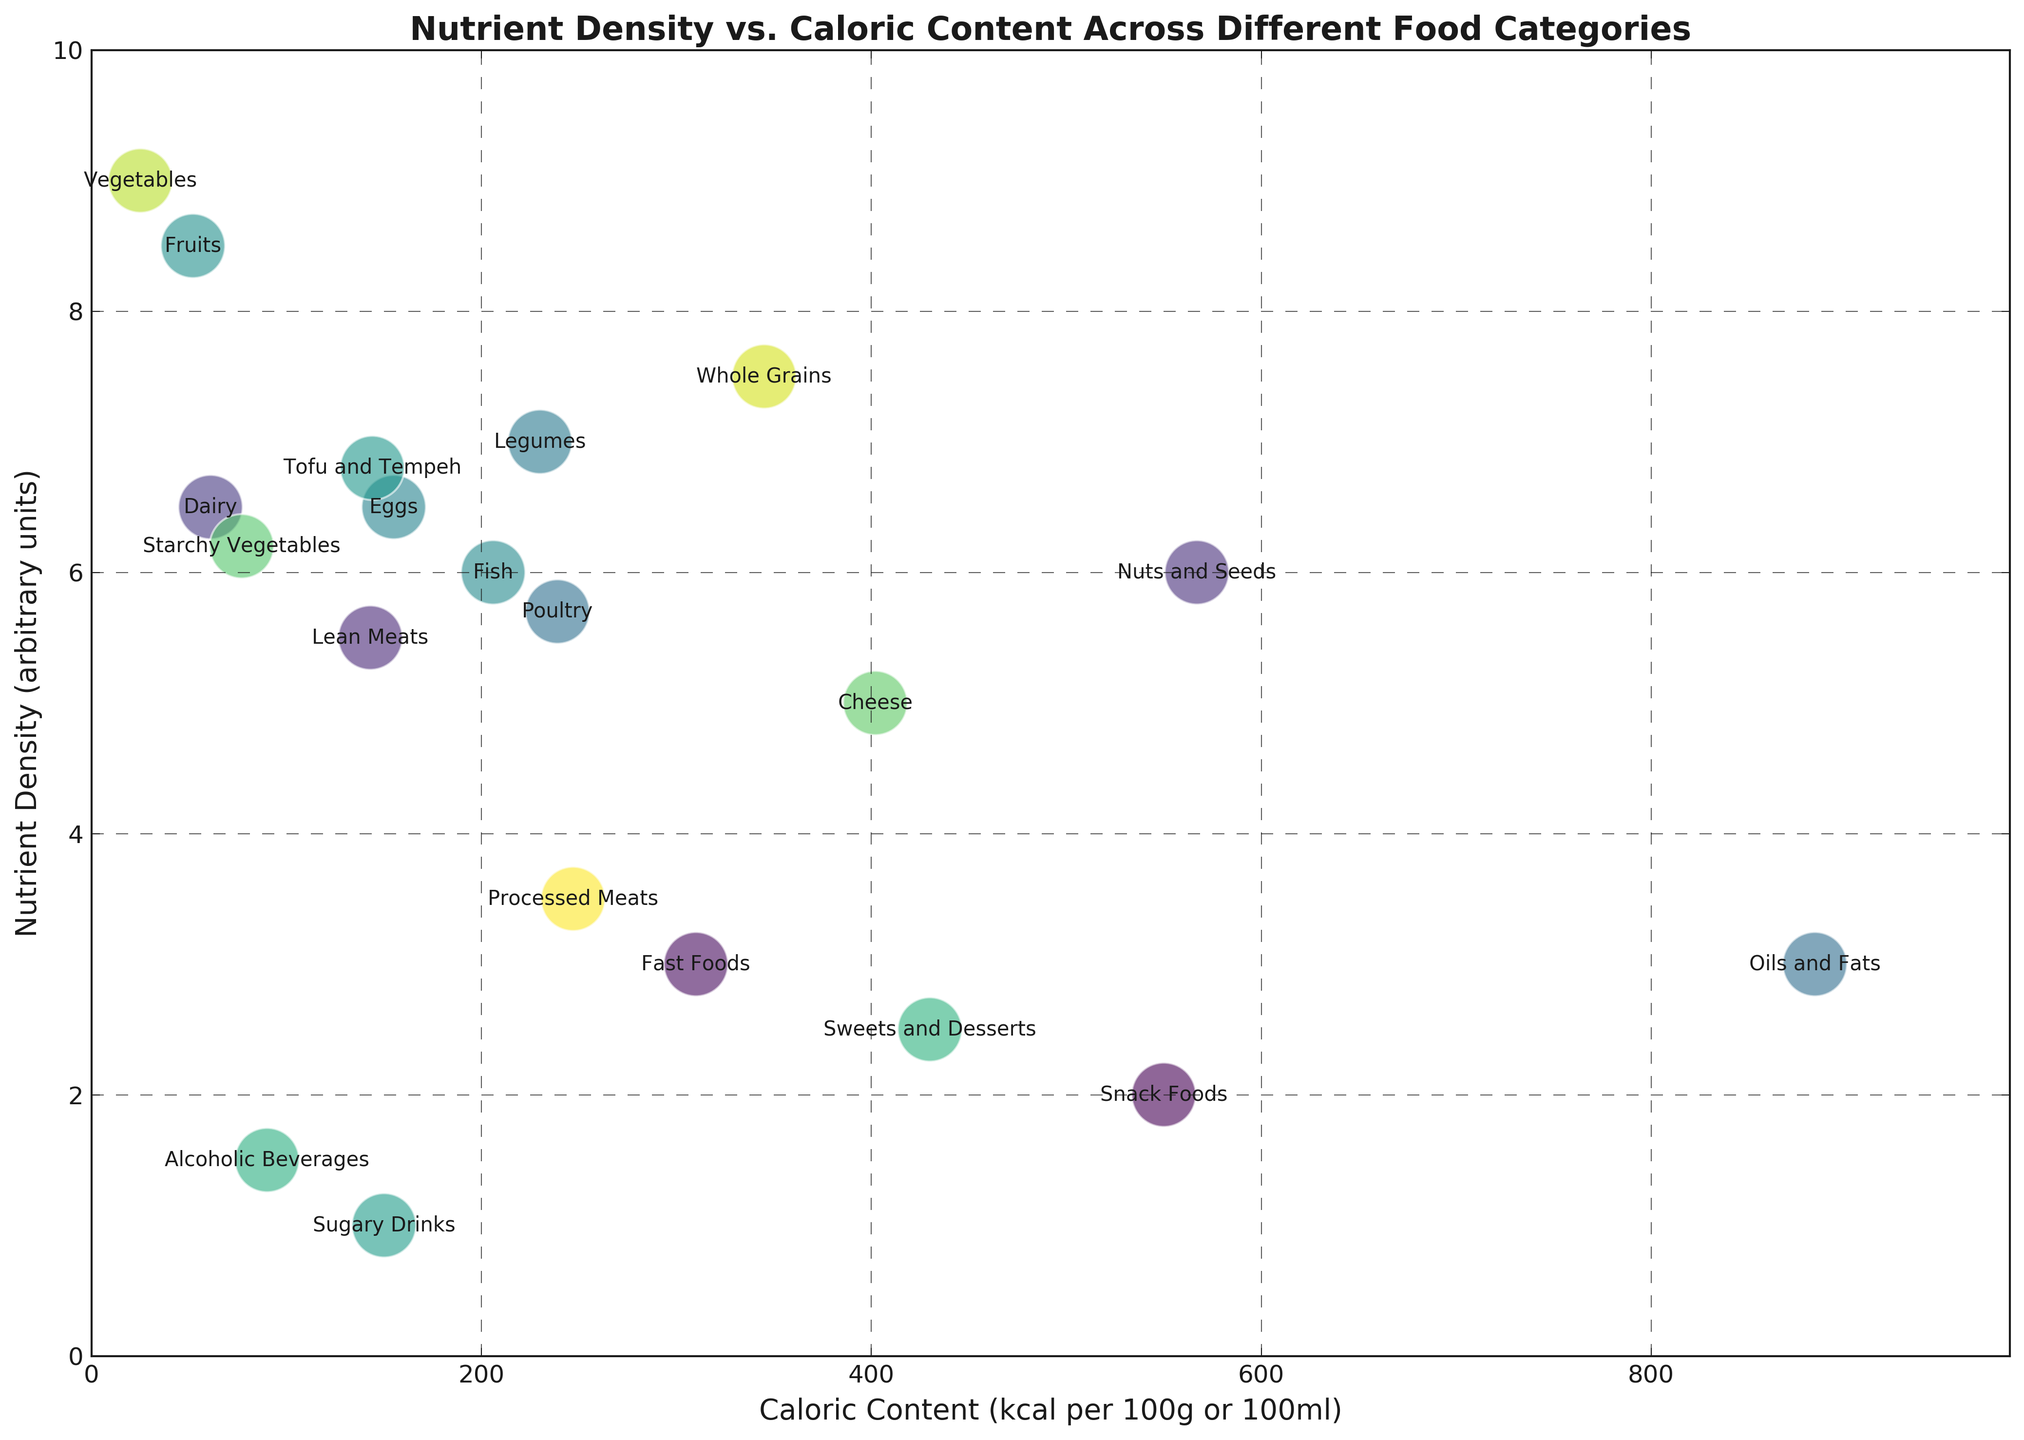Which food category has the highest nutrient density? First, locate the y-axis, which represents nutrient density. Then, find the point that is the highest on the y-axis. "Vegetables" is at the topmost point.
Answer: Vegetables Which food categories have a caloric content greater than 500 kcal per 100g or 100ml? Locate the x-axis and find the points that are positioned to the right of the 500 kcal mark. The categories "Nuts and Seeds," "Snack Foods," "Oils and Fats," and "Sweets and Desserts" are all beyond this mark.
Answer: Nuts and Seeds, Snack Foods, Oils and Fats, Sweets and Desserts What is the difference in caloric content between the food category with the highest and lowest caloric content? Find the point farthest right on the x-axis, which is "Oils and Fats" with 884 kcal. Then, find the point closest to the y-axis, which is "Vegetables" with 25 kcal. Subtract 25 from 884.
Answer: 859 kcal Which has a higher nutrient density between "Legumes" and "Cheese," and by how much? Find the y-values of "Legumes" and "Cheese." "Legumes" has a nutrient density of 7 and "Cheese" has a nutrient density of 5. Subtract the nutrient density of Cheese from Legumes (7 - 5).
Answer: Legumes by 2 Are there any food categories with both high caloric content (greater than 400 kcal) and high nutrient density (greater than 6)? Identify points with an x-axis value greater than 400 and a y-axis value greater than 6. Only "Sweets and Desserts" fits this criteria.
Answer: Sweets and Desserts What is the average caloric content of "Fruits," "Vegetables," and "Whole Grains"? Find the caloric values: Fruits (52 kcal), Vegetables (25 kcal), and Whole Grains (345 kcal). Sum them up (52 + 25 + 345 = 422) and then divide by 3.
Answer: 140.67 kcal Which food category stands out as having a low nutrient density but relatively high caloric content? Locate points with low y-values and high x-values. "Snack Foods" has a nutrient density of 2 and a caloric content of 550 kcal, standing out in this aspect.
Answer: Snack Foods Compare the nutrient density and caloric content of "Dairy" and "Sugary Drinks". Which one has a higher nutrient density and which one has a higher caloric content? Find dairy with nutrient density 6.5 and caloric content 61, and sugary drinks with nutrient density 1 and caloric content 150. Dairy is higher in nutrient density, while sugary drinks have higher caloric content.
Answer: Dairy has higher nutrient density; Sugary Drinks have higher caloric content What is the difference in nutrient density between "Lean Meats" and "Fish"? Find the y-values for "Lean Meats" (5.5) and "Fish" (6). Subtract the smaller value from the larger one (6 - 5.5).
Answer: 0.5 